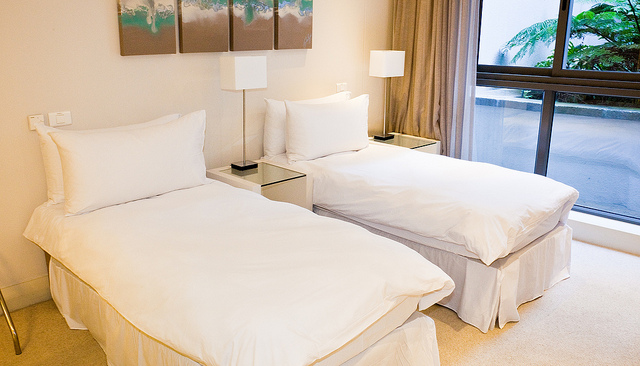What style of decor is used in this bedroom? The bedroom features a contemporary style with minimalistic furniture, neutral color tones, and clean lines evident in the bed frames and side tables. The artwork above the beds adds a touch of color to the room. 